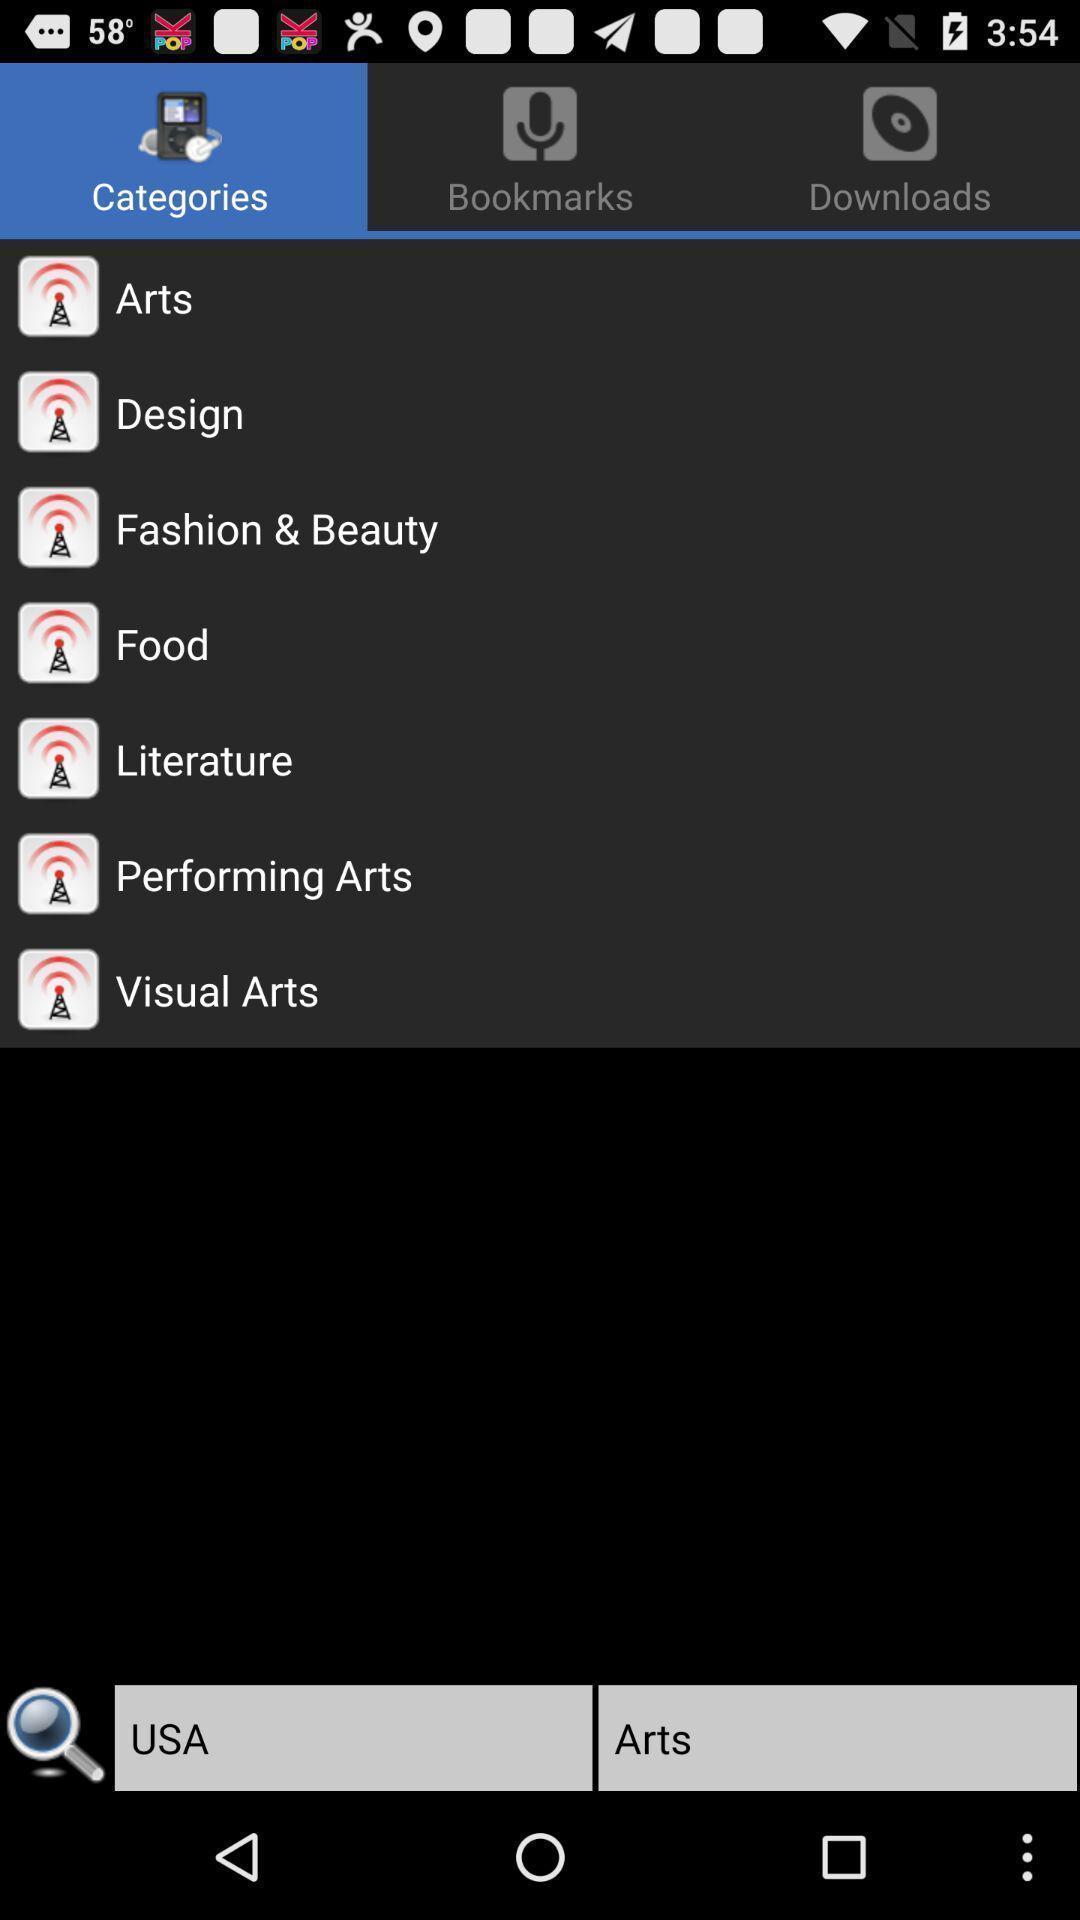Please provide a description for this image. Various categories in a podcast app. 